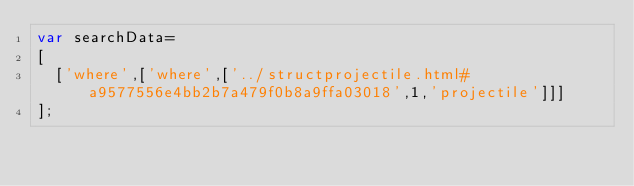<code> <loc_0><loc_0><loc_500><loc_500><_JavaScript_>var searchData=
[
  ['where',['where',['../structprojectile.html#a9577556e4bb2b7a479f0b8a9ffa03018',1,'projectile']]]
];
</code> 